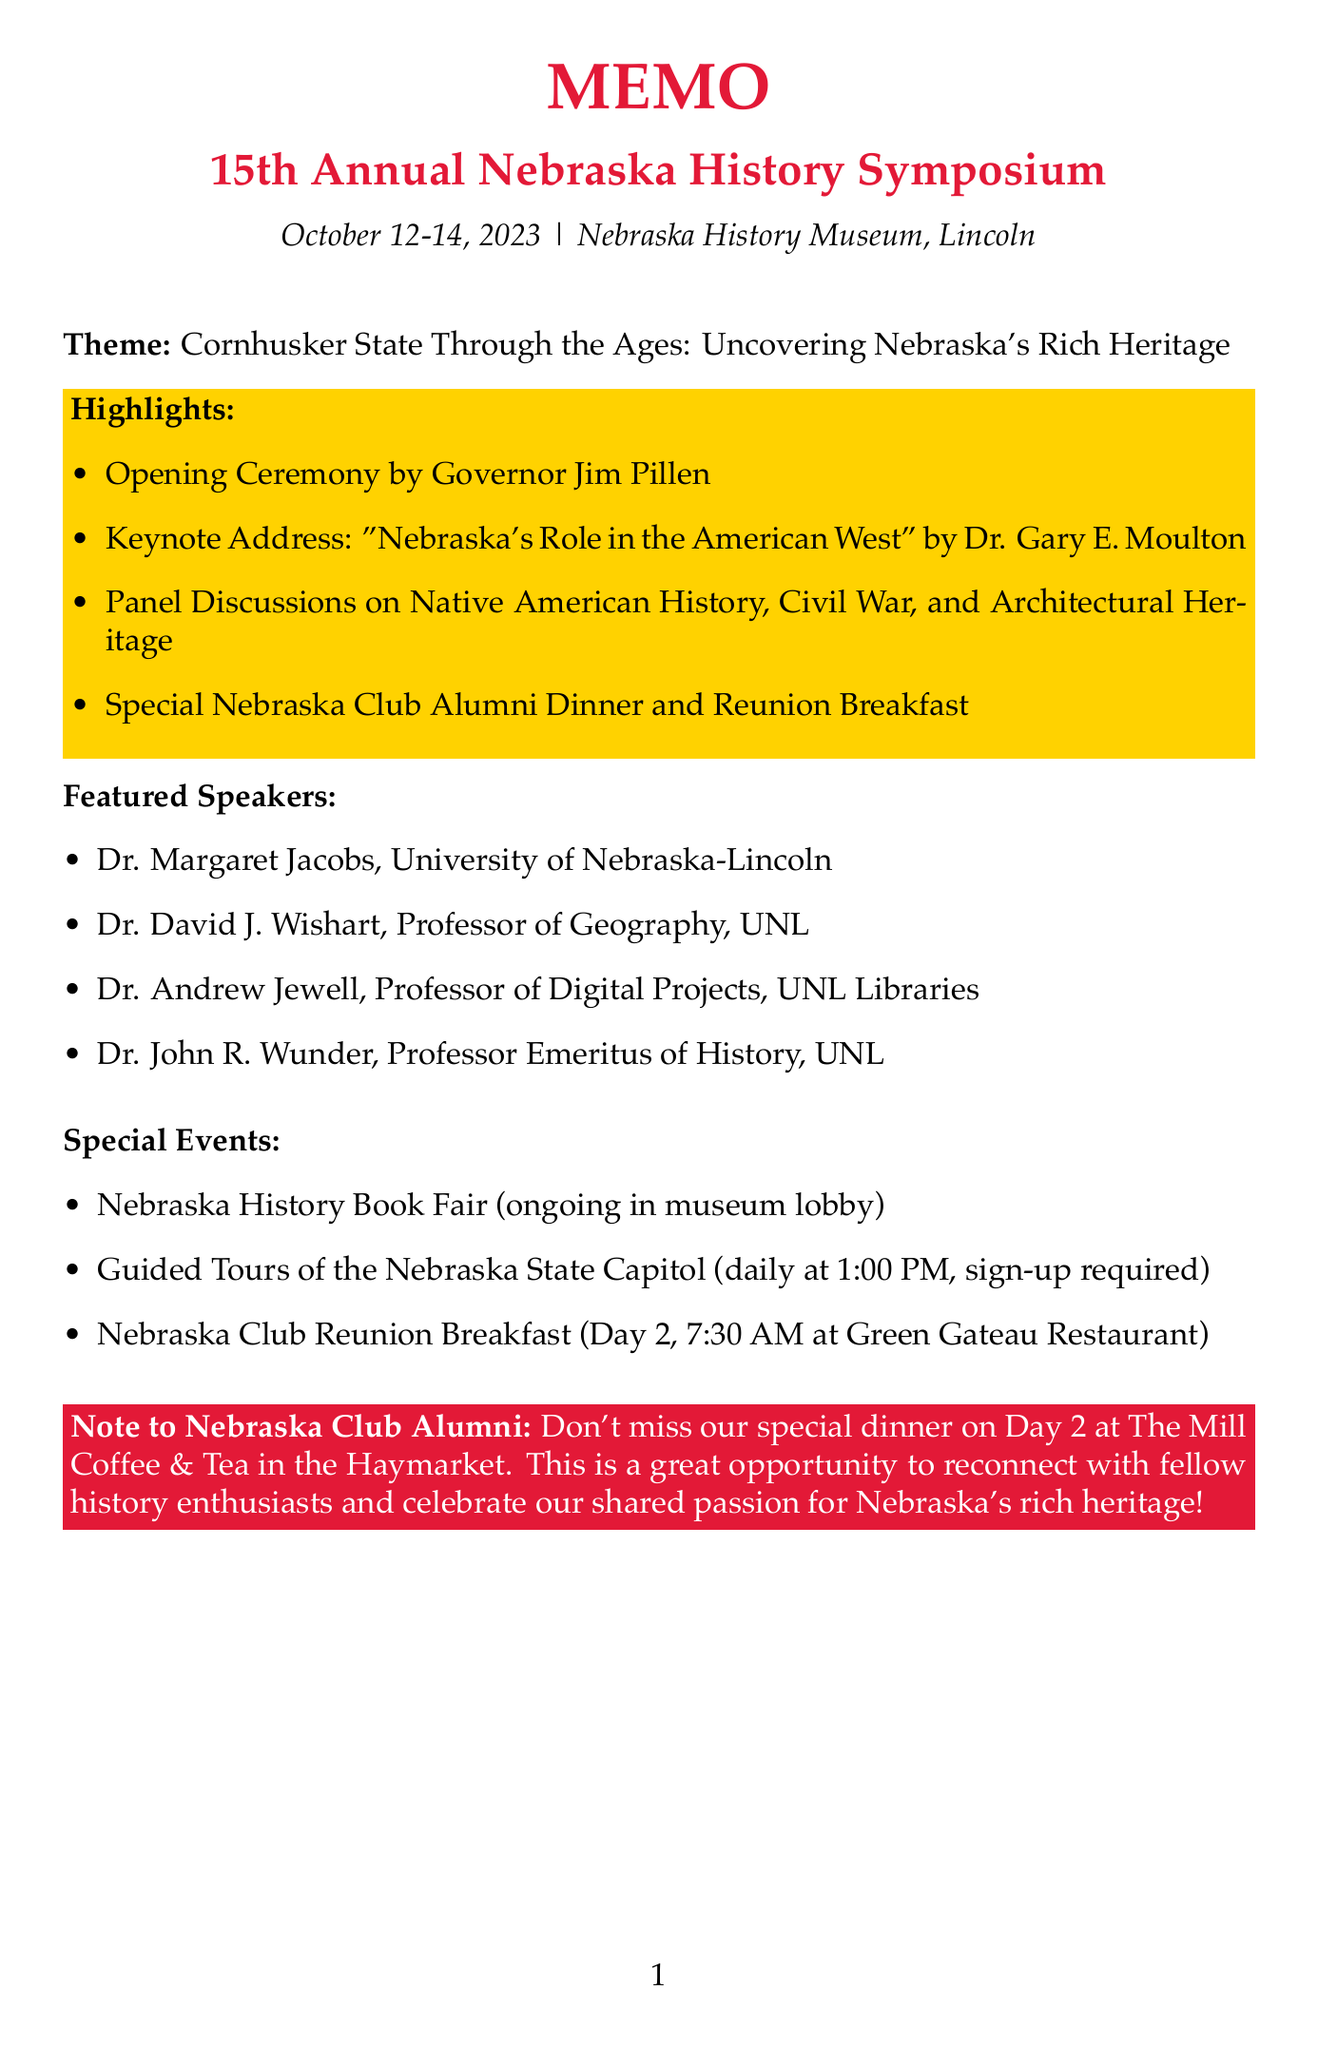What is the title of the symposium? The title of the symposium is explicitly provided in the memo.
Answer: 15th Annual Nebraska History Symposium Who is the keynote speaker on Day 1? The keynote speaker is mentioned in the agenda for Day 1, highlighting the specific event and speaker.
Answer: Dr. Gary E. Moulton What is the location of the Nebraska Club Alumni Dinner? The location of the dinner is provided in the agenda for Day 2 under the event listing.
Answer: The Mill Coffee & Tea in the Haymarket On which day is the Nebraska Club Reunion Breakfast scheduled? The specific day for this event is mentioned in the special events section of the memo.
Answer: Day 2 What is the theme of the symposium? The theme is clearly stated at the beginning of the memo.
Answer: Cornhusker State Through the Ages: Uncovering Nebraska's Rich Heritage How many days will the symposium last? The duration is specified in the date section of the memo.
Answer: Three days What time do the guided tours of the Nebraska State Capitol start? The starting time is indicated in the description of the guided tours under special events.
Answer: 1:00 PM Who is facilitating the workshop on Day 2? The facilitator's name is given in the agenda for Day 2, specifically under the workshop event.
Answer: Jill Dolberg 